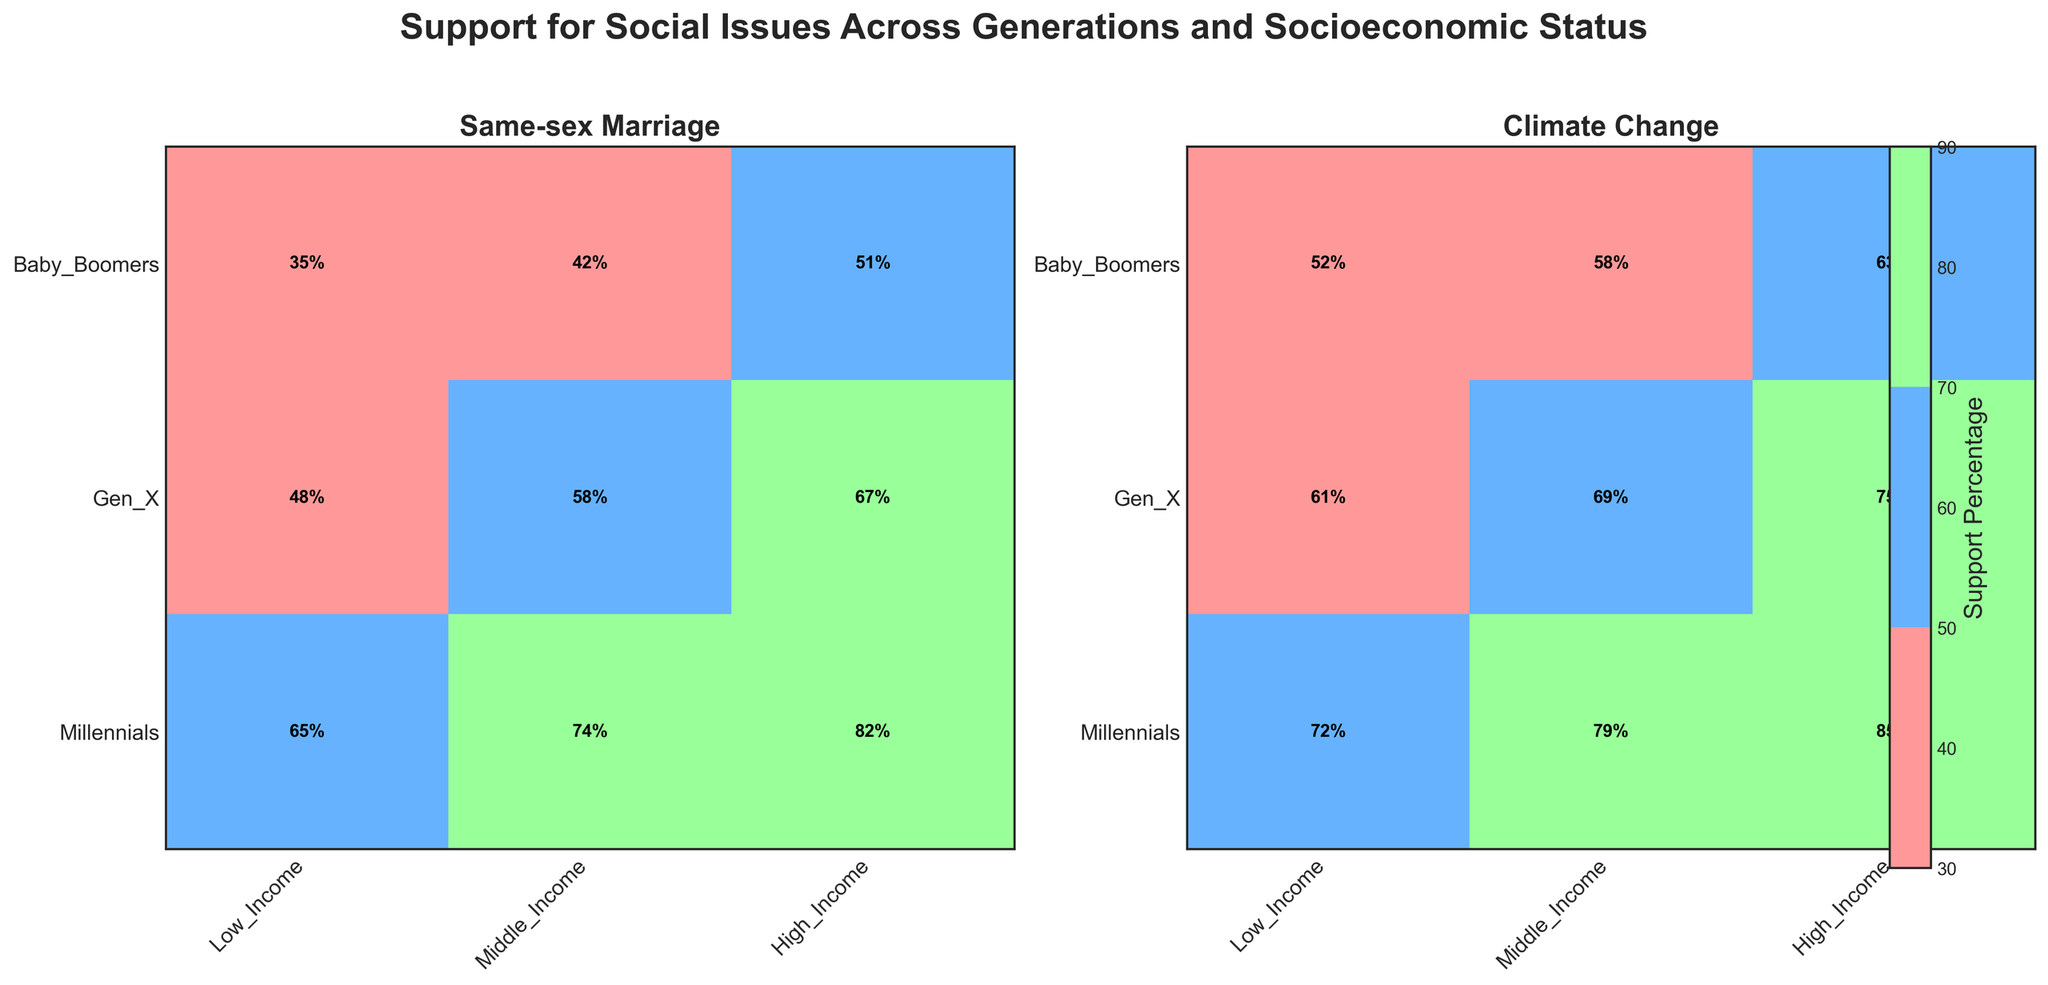What are the social issues featured in the mosaic plot? The mosaic plot has titles for each subplot indicating the featured social issues. The titles of the subplots are "Same-sex Marriage" and "Climate Change."
Answer: Same-sex Marriage, Climate Change Which generation shows the highest support percentage for Same-sex Marriage across all socioeconomic statuses? The Millennial generation, with support percentages of 65% (Low Income), 74% (Middle Income), and 82% (High Income), shows the highest support across all socioeconomic statuses for Same-sex Marriage.
Answer: Millennials How does support for Climate Change among Baby Boomers compare across different socioeconomic statuses? We need to look at Baby Boomers' support percentages for Climate Change across Low Income (52%), Middle Income (58%), and High Income (63%). Support increases as socioeconomic status rises.
Answer: Low > Middle > High What is the difference in support percentages for Same-sex Marriage between Baby Boomers and Millennials in the Middle Income group? The support percentage for Baby Boomers in Middle Income is 42%. For Millennials, it is 74%. The difference is 74% - 42% = 32%.
Answer: 32% What is the average support for Climate Change among Millennials across all socioeconomic statuses? Support percentages for Millennials regarding Climate Change are 72% (Low Income), 79% (Middle Income), and 85% (High Income). The average is (72% + 79% + 85%) / 3 = 78.67%.
Answer: 78.67% Which socioeconomic group has the smallest increase in support for Climate Change from Gen X to Millennials? To find the smallest increase, compare the differences in support for Low (72%-61%), Middle (79%-69%), and High Income (85%-75%). The smallest increase is 72% - 61% = 11%.
Answer: Low Income What is the overall trend for support on Same-sex Marriage across generations? Observing the support percentages for each generation: Baby Boomers (35%-51%), Gen X (48%-67%), and Millennials (65%-82%), we see an increasing trend in support for Same-sex Marriage across newer generations.
Answer: Increasing How does support for Same-sex Marriage among Low-Income individuals compare between Baby Boomers and Gen X? Support among Low-Income individuals for Baby Boomers is 35% and for Gen X is 48%. Comparing these, support has increased by 13% in Gen X.
Answer: Increased by 13% For the issue of Climate Change, which generation has the smallest range of support percentages across different socioeconomic statuses? Calculate the range for each generation: Baby Boomers (63%-52%=11), Gen X (75%-61%=14), and Millennials (85%-72%=13). The smallest range is 11 for Baby Boomers.
Answer: Baby Boomers 